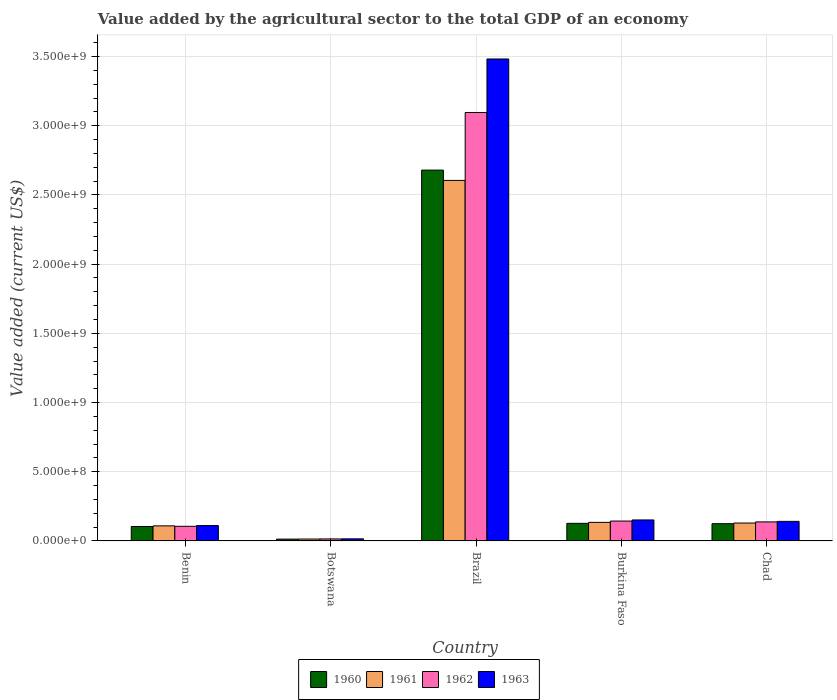How many different coloured bars are there?
Keep it short and to the point. 4. Are the number of bars per tick equal to the number of legend labels?
Make the answer very short. Yes. Are the number of bars on each tick of the X-axis equal?
Provide a short and direct response. Yes. What is the label of the 4th group of bars from the left?
Make the answer very short. Burkina Faso. In how many cases, is the number of bars for a given country not equal to the number of legend labels?
Give a very brief answer. 0. What is the value added by the agricultural sector to the total GDP in 1960 in Brazil?
Provide a short and direct response. 2.68e+09. Across all countries, what is the maximum value added by the agricultural sector to the total GDP in 1960?
Ensure brevity in your answer.  2.68e+09. Across all countries, what is the minimum value added by the agricultural sector to the total GDP in 1963?
Offer a terse response. 1.51e+07. In which country was the value added by the agricultural sector to the total GDP in 1960 minimum?
Keep it short and to the point. Botswana. What is the total value added by the agricultural sector to the total GDP in 1961 in the graph?
Your answer should be compact. 2.99e+09. What is the difference between the value added by the agricultural sector to the total GDP in 1962 in Botswana and that in Chad?
Provide a short and direct response. -1.23e+08. What is the difference between the value added by the agricultural sector to the total GDP in 1963 in Chad and the value added by the agricultural sector to the total GDP in 1961 in Burkina Faso?
Offer a terse response. 7.20e+06. What is the average value added by the agricultural sector to the total GDP in 1963 per country?
Provide a succinct answer. 7.80e+08. What is the difference between the value added by the agricultural sector to the total GDP of/in 1962 and value added by the agricultural sector to the total GDP of/in 1961 in Benin?
Make the answer very short. -3.16e+06. What is the ratio of the value added by the agricultural sector to the total GDP in 1961 in Benin to that in Burkina Faso?
Offer a terse response. 0.81. Is the difference between the value added by the agricultural sector to the total GDP in 1962 in Botswana and Chad greater than the difference between the value added by the agricultural sector to the total GDP in 1961 in Botswana and Chad?
Offer a terse response. No. What is the difference between the highest and the second highest value added by the agricultural sector to the total GDP in 1960?
Your response must be concise. -2.55e+09. What is the difference between the highest and the lowest value added by the agricultural sector to the total GDP in 1960?
Provide a short and direct response. 2.67e+09. Is the sum of the value added by the agricultural sector to the total GDP in 1960 in Botswana and Burkina Faso greater than the maximum value added by the agricultural sector to the total GDP in 1961 across all countries?
Ensure brevity in your answer.  No. What does the 4th bar from the left in Benin represents?
Provide a short and direct response. 1963. Is it the case that in every country, the sum of the value added by the agricultural sector to the total GDP in 1963 and value added by the agricultural sector to the total GDP in 1960 is greater than the value added by the agricultural sector to the total GDP in 1962?
Keep it short and to the point. Yes. How many bars are there?
Offer a terse response. 20. How many countries are there in the graph?
Provide a short and direct response. 5. What is the difference between two consecutive major ticks on the Y-axis?
Offer a terse response. 5.00e+08. Are the values on the major ticks of Y-axis written in scientific E-notation?
Your answer should be compact. Yes. Does the graph contain grids?
Your answer should be very brief. Yes. Where does the legend appear in the graph?
Provide a succinct answer. Bottom center. What is the title of the graph?
Keep it short and to the point. Value added by the agricultural sector to the total GDP of an economy. What is the label or title of the Y-axis?
Your answer should be compact. Value added (current US$). What is the Value added (current US$) of 1960 in Benin?
Your response must be concise. 1.04e+08. What is the Value added (current US$) in 1961 in Benin?
Keep it short and to the point. 1.09e+08. What is the Value added (current US$) in 1962 in Benin?
Make the answer very short. 1.06e+08. What is the Value added (current US$) of 1963 in Benin?
Give a very brief answer. 1.11e+08. What is the Value added (current US$) in 1960 in Botswana?
Provide a succinct answer. 1.31e+07. What is the Value added (current US$) in 1961 in Botswana?
Your response must be concise. 1.38e+07. What is the Value added (current US$) in 1962 in Botswana?
Provide a succinct answer. 1.45e+07. What is the Value added (current US$) of 1963 in Botswana?
Make the answer very short. 1.51e+07. What is the Value added (current US$) of 1960 in Brazil?
Make the answer very short. 2.68e+09. What is the Value added (current US$) in 1961 in Brazil?
Keep it short and to the point. 2.60e+09. What is the Value added (current US$) in 1962 in Brazil?
Provide a short and direct response. 3.10e+09. What is the Value added (current US$) in 1963 in Brazil?
Your answer should be compact. 3.48e+09. What is the Value added (current US$) in 1960 in Burkina Faso?
Make the answer very short. 1.27e+08. What is the Value added (current US$) of 1961 in Burkina Faso?
Ensure brevity in your answer.  1.34e+08. What is the Value added (current US$) in 1962 in Burkina Faso?
Provide a short and direct response. 1.44e+08. What is the Value added (current US$) in 1963 in Burkina Faso?
Your answer should be very brief. 1.52e+08. What is the Value added (current US$) of 1960 in Chad?
Offer a very short reply. 1.25e+08. What is the Value added (current US$) in 1961 in Chad?
Your answer should be compact. 1.29e+08. What is the Value added (current US$) in 1962 in Chad?
Ensure brevity in your answer.  1.38e+08. What is the Value added (current US$) in 1963 in Chad?
Offer a terse response. 1.41e+08. Across all countries, what is the maximum Value added (current US$) in 1960?
Your answer should be very brief. 2.68e+09. Across all countries, what is the maximum Value added (current US$) in 1961?
Keep it short and to the point. 2.60e+09. Across all countries, what is the maximum Value added (current US$) in 1962?
Provide a short and direct response. 3.10e+09. Across all countries, what is the maximum Value added (current US$) of 1963?
Provide a short and direct response. 3.48e+09. Across all countries, what is the minimum Value added (current US$) in 1960?
Offer a terse response. 1.31e+07. Across all countries, what is the minimum Value added (current US$) of 1961?
Offer a terse response. 1.38e+07. Across all countries, what is the minimum Value added (current US$) of 1962?
Ensure brevity in your answer.  1.45e+07. Across all countries, what is the minimum Value added (current US$) of 1963?
Keep it short and to the point. 1.51e+07. What is the total Value added (current US$) of 1960 in the graph?
Make the answer very short. 3.05e+09. What is the total Value added (current US$) in 1961 in the graph?
Provide a succinct answer. 2.99e+09. What is the total Value added (current US$) in 1962 in the graph?
Give a very brief answer. 3.50e+09. What is the total Value added (current US$) of 1963 in the graph?
Your answer should be very brief. 3.90e+09. What is the difference between the Value added (current US$) of 1960 in Benin and that in Botswana?
Ensure brevity in your answer.  9.13e+07. What is the difference between the Value added (current US$) in 1961 in Benin and that in Botswana?
Your answer should be very brief. 9.51e+07. What is the difference between the Value added (current US$) in 1962 in Benin and that in Botswana?
Provide a short and direct response. 9.12e+07. What is the difference between the Value added (current US$) of 1963 in Benin and that in Botswana?
Give a very brief answer. 9.59e+07. What is the difference between the Value added (current US$) in 1960 in Benin and that in Brazil?
Give a very brief answer. -2.57e+09. What is the difference between the Value added (current US$) in 1961 in Benin and that in Brazil?
Provide a succinct answer. -2.50e+09. What is the difference between the Value added (current US$) of 1962 in Benin and that in Brazil?
Provide a succinct answer. -2.99e+09. What is the difference between the Value added (current US$) of 1963 in Benin and that in Brazil?
Keep it short and to the point. -3.37e+09. What is the difference between the Value added (current US$) of 1960 in Benin and that in Burkina Faso?
Ensure brevity in your answer.  -2.28e+07. What is the difference between the Value added (current US$) of 1961 in Benin and that in Burkina Faso?
Give a very brief answer. -2.53e+07. What is the difference between the Value added (current US$) of 1962 in Benin and that in Burkina Faso?
Your response must be concise. -3.80e+07. What is the difference between the Value added (current US$) in 1963 in Benin and that in Burkina Faso?
Offer a very short reply. -4.07e+07. What is the difference between the Value added (current US$) of 1960 in Benin and that in Chad?
Offer a terse response. -2.02e+07. What is the difference between the Value added (current US$) of 1961 in Benin and that in Chad?
Give a very brief answer. -2.05e+07. What is the difference between the Value added (current US$) of 1962 in Benin and that in Chad?
Provide a short and direct response. -3.19e+07. What is the difference between the Value added (current US$) in 1963 in Benin and that in Chad?
Offer a terse response. -3.04e+07. What is the difference between the Value added (current US$) of 1960 in Botswana and that in Brazil?
Provide a short and direct response. -2.67e+09. What is the difference between the Value added (current US$) in 1961 in Botswana and that in Brazil?
Your response must be concise. -2.59e+09. What is the difference between the Value added (current US$) of 1962 in Botswana and that in Brazil?
Give a very brief answer. -3.08e+09. What is the difference between the Value added (current US$) in 1963 in Botswana and that in Brazil?
Your response must be concise. -3.47e+09. What is the difference between the Value added (current US$) of 1960 in Botswana and that in Burkina Faso?
Give a very brief answer. -1.14e+08. What is the difference between the Value added (current US$) in 1961 in Botswana and that in Burkina Faso?
Make the answer very short. -1.20e+08. What is the difference between the Value added (current US$) in 1962 in Botswana and that in Burkina Faso?
Your answer should be very brief. -1.29e+08. What is the difference between the Value added (current US$) of 1963 in Botswana and that in Burkina Faso?
Your answer should be very brief. -1.37e+08. What is the difference between the Value added (current US$) in 1960 in Botswana and that in Chad?
Your answer should be very brief. -1.11e+08. What is the difference between the Value added (current US$) of 1961 in Botswana and that in Chad?
Provide a succinct answer. -1.16e+08. What is the difference between the Value added (current US$) in 1962 in Botswana and that in Chad?
Your answer should be very brief. -1.23e+08. What is the difference between the Value added (current US$) in 1963 in Botswana and that in Chad?
Your answer should be very brief. -1.26e+08. What is the difference between the Value added (current US$) of 1960 in Brazil and that in Burkina Faso?
Offer a terse response. 2.55e+09. What is the difference between the Value added (current US$) in 1961 in Brazil and that in Burkina Faso?
Ensure brevity in your answer.  2.47e+09. What is the difference between the Value added (current US$) in 1962 in Brazil and that in Burkina Faso?
Your answer should be very brief. 2.95e+09. What is the difference between the Value added (current US$) in 1963 in Brazil and that in Burkina Faso?
Keep it short and to the point. 3.33e+09. What is the difference between the Value added (current US$) in 1960 in Brazil and that in Chad?
Keep it short and to the point. 2.55e+09. What is the difference between the Value added (current US$) of 1961 in Brazil and that in Chad?
Make the answer very short. 2.48e+09. What is the difference between the Value added (current US$) of 1962 in Brazil and that in Chad?
Offer a very short reply. 2.96e+09. What is the difference between the Value added (current US$) in 1963 in Brazil and that in Chad?
Your answer should be very brief. 3.34e+09. What is the difference between the Value added (current US$) of 1960 in Burkina Faso and that in Chad?
Give a very brief answer. 2.61e+06. What is the difference between the Value added (current US$) of 1961 in Burkina Faso and that in Chad?
Make the answer very short. 4.79e+06. What is the difference between the Value added (current US$) of 1962 in Burkina Faso and that in Chad?
Offer a very short reply. 6.10e+06. What is the difference between the Value added (current US$) of 1963 in Burkina Faso and that in Chad?
Offer a terse response. 1.03e+07. What is the difference between the Value added (current US$) of 1960 in Benin and the Value added (current US$) of 1961 in Botswana?
Make the answer very short. 9.06e+07. What is the difference between the Value added (current US$) in 1960 in Benin and the Value added (current US$) in 1962 in Botswana?
Make the answer very short. 8.99e+07. What is the difference between the Value added (current US$) of 1960 in Benin and the Value added (current US$) of 1963 in Botswana?
Provide a short and direct response. 8.93e+07. What is the difference between the Value added (current US$) in 1961 in Benin and the Value added (current US$) in 1962 in Botswana?
Make the answer very short. 9.44e+07. What is the difference between the Value added (current US$) of 1961 in Benin and the Value added (current US$) of 1963 in Botswana?
Offer a terse response. 9.37e+07. What is the difference between the Value added (current US$) of 1962 in Benin and the Value added (current US$) of 1963 in Botswana?
Make the answer very short. 9.06e+07. What is the difference between the Value added (current US$) of 1960 in Benin and the Value added (current US$) of 1961 in Brazil?
Your response must be concise. -2.50e+09. What is the difference between the Value added (current US$) of 1960 in Benin and the Value added (current US$) of 1962 in Brazil?
Your response must be concise. -2.99e+09. What is the difference between the Value added (current US$) of 1960 in Benin and the Value added (current US$) of 1963 in Brazil?
Provide a succinct answer. -3.38e+09. What is the difference between the Value added (current US$) of 1961 in Benin and the Value added (current US$) of 1962 in Brazil?
Provide a short and direct response. -2.99e+09. What is the difference between the Value added (current US$) of 1961 in Benin and the Value added (current US$) of 1963 in Brazil?
Offer a terse response. -3.37e+09. What is the difference between the Value added (current US$) of 1962 in Benin and the Value added (current US$) of 1963 in Brazil?
Keep it short and to the point. -3.38e+09. What is the difference between the Value added (current US$) of 1960 in Benin and the Value added (current US$) of 1961 in Burkina Faso?
Provide a succinct answer. -2.98e+07. What is the difference between the Value added (current US$) in 1960 in Benin and the Value added (current US$) in 1962 in Burkina Faso?
Your answer should be very brief. -3.93e+07. What is the difference between the Value added (current US$) in 1960 in Benin and the Value added (current US$) in 1963 in Burkina Faso?
Ensure brevity in your answer.  -4.73e+07. What is the difference between the Value added (current US$) of 1961 in Benin and the Value added (current US$) of 1962 in Burkina Faso?
Make the answer very short. -3.48e+07. What is the difference between the Value added (current US$) in 1961 in Benin and the Value added (current US$) in 1963 in Burkina Faso?
Your response must be concise. -4.28e+07. What is the difference between the Value added (current US$) of 1962 in Benin and the Value added (current US$) of 1963 in Burkina Faso?
Your answer should be compact. -4.60e+07. What is the difference between the Value added (current US$) in 1960 in Benin and the Value added (current US$) in 1961 in Chad?
Your answer should be compact. -2.50e+07. What is the difference between the Value added (current US$) in 1960 in Benin and the Value added (current US$) in 1962 in Chad?
Offer a terse response. -3.32e+07. What is the difference between the Value added (current US$) in 1960 in Benin and the Value added (current US$) in 1963 in Chad?
Ensure brevity in your answer.  -3.70e+07. What is the difference between the Value added (current US$) in 1961 in Benin and the Value added (current US$) in 1962 in Chad?
Your answer should be compact. -2.87e+07. What is the difference between the Value added (current US$) of 1961 in Benin and the Value added (current US$) of 1963 in Chad?
Give a very brief answer. -3.25e+07. What is the difference between the Value added (current US$) of 1962 in Benin and the Value added (current US$) of 1963 in Chad?
Offer a very short reply. -3.57e+07. What is the difference between the Value added (current US$) in 1960 in Botswana and the Value added (current US$) in 1961 in Brazil?
Your answer should be very brief. -2.59e+09. What is the difference between the Value added (current US$) of 1960 in Botswana and the Value added (current US$) of 1962 in Brazil?
Ensure brevity in your answer.  -3.08e+09. What is the difference between the Value added (current US$) of 1960 in Botswana and the Value added (current US$) of 1963 in Brazil?
Provide a succinct answer. -3.47e+09. What is the difference between the Value added (current US$) in 1961 in Botswana and the Value added (current US$) in 1962 in Brazil?
Provide a succinct answer. -3.08e+09. What is the difference between the Value added (current US$) of 1961 in Botswana and the Value added (current US$) of 1963 in Brazil?
Ensure brevity in your answer.  -3.47e+09. What is the difference between the Value added (current US$) of 1962 in Botswana and the Value added (current US$) of 1963 in Brazil?
Your answer should be very brief. -3.47e+09. What is the difference between the Value added (current US$) of 1960 in Botswana and the Value added (current US$) of 1961 in Burkina Faso?
Make the answer very short. -1.21e+08. What is the difference between the Value added (current US$) in 1960 in Botswana and the Value added (current US$) in 1962 in Burkina Faso?
Ensure brevity in your answer.  -1.31e+08. What is the difference between the Value added (current US$) in 1960 in Botswana and the Value added (current US$) in 1963 in Burkina Faso?
Ensure brevity in your answer.  -1.39e+08. What is the difference between the Value added (current US$) of 1961 in Botswana and the Value added (current US$) of 1962 in Burkina Faso?
Make the answer very short. -1.30e+08. What is the difference between the Value added (current US$) of 1961 in Botswana and the Value added (current US$) of 1963 in Burkina Faso?
Provide a short and direct response. -1.38e+08. What is the difference between the Value added (current US$) in 1962 in Botswana and the Value added (current US$) in 1963 in Burkina Faso?
Provide a succinct answer. -1.37e+08. What is the difference between the Value added (current US$) of 1960 in Botswana and the Value added (current US$) of 1961 in Chad?
Make the answer very short. -1.16e+08. What is the difference between the Value added (current US$) of 1960 in Botswana and the Value added (current US$) of 1962 in Chad?
Your answer should be very brief. -1.24e+08. What is the difference between the Value added (current US$) in 1960 in Botswana and the Value added (current US$) in 1963 in Chad?
Make the answer very short. -1.28e+08. What is the difference between the Value added (current US$) of 1961 in Botswana and the Value added (current US$) of 1962 in Chad?
Your answer should be very brief. -1.24e+08. What is the difference between the Value added (current US$) in 1961 in Botswana and the Value added (current US$) in 1963 in Chad?
Your answer should be compact. -1.28e+08. What is the difference between the Value added (current US$) in 1962 in Botswana and the Value added (current US$) in 1963 in Chad?
Provide a succinct answer. -1.27e+08. What is the difference between the Value added (current US$) in 1960 in Brazil and the Value added (current US$) in 1961 in Burkina Faso?
Provide a short and direct response. 2.55e+09. What is the difference between the Value added (current US$) in 1960 in Brazil and the Value added (current US$) in 1962 in Burkina Faso?
Ensure brevity in your answer.  2.54e+09. What is the difference between the Value added (current US$) of 1960 in Brazil and the Value added (current US$) of 1963 in Burkina Faso?
Your response must be concise. 2.53e+09. What is the difference between the Value added (current US$) in 1961 in Brazil and the Value added (current US$) in 1962 in Burkina Faso?
Your answer should be very brief. 2.46e+09. What is the difference between the Value added (current US$) in 1961 in Brazil and the Value added (current US$) in 1963 in Burkina Faso?
Give a very brief answer. 2.45e+09. What is the difference between the Value added (current US$) of 1962 in Brazil and the Value added (current US$) of 1963 in Burkina Faso?
Provide a succinct answer. 2.94e+09. What is the difference between the Value added (current US$) in 1960 in Brazil and the Value added (current US$) in 1961 in Chad?
Ensure brevity in your answer.  2.55e+09. What is the difference between the Value added (current US$) in 1960 in Brazil and the Value added (current US$) in 1962 in Chad?
Provide a short and direct response. 2.54e+09. What is the difference between the Value added (current US$) of 1960 in Brazil and the Value added (current US$) of 1963 in Chad?
Offer a terse response. 2.54e+09. What is the difference between the Value added (current US$) in 1961 in Brazil and the Value added (current US$) in 1962 in Chad?
Provide a succinct answer. 2.47e+09. What is the difference between the Value added (current US$) of 1961 in Brazil and the Value added (current US$) of 1963 in Chad?
Your answer should be compact. 2.46e+09. What is the difference between the Value added (current US$) in 1962 in Brazil and the Value added (current US$) in 1963 in Chad?
Ensure brevity in your answer.  2.95e+09. What is the difference between the Value added (current US$) in 1960 in Burkina Faso and the Value added (current US$) in 1961 in Chad?
Offer a very short reply. -2.21e+06. What is the difference between the Value added (current US$) in 1960 in Burkina Faso and the Value added (current US$) in 1962 in Chad?
Make the answer very short. -1.04e+07. What is the difference between the Value added (current US$) of 1960 in Burkina Faso and the Value added (current US$) of 1963 in Chad?
Ensure brevity in your answer.  -1.42e+07. What is the difference between the Value added (current US$) in 1961 in Burkina Faso and the Value added (current US$) in 1962 in Chad?
Keep it short and to the point. -3.43e+06. What is the difference between the Value added (current US$) of 1961 in Burkina Faso and the Value added (current US$) of 1963 in Chad?
Offer a terse response. -7.20e+06. What is the difference between the Value added (current US$) of 1962 in Burkina Faso and the Value added (current US$) of 1963 in Chad?
Provide a succinct answer. 2.33e+06. What is the average Value added (current US$) of 1960 per country?
Offer a very short reply. 6.10e+08. What is the average Value added (current US$) in 1961 per country?
Offer a terse response. 5.98e+08. What is the average Value added (current US$) in 1962 per country?
Your response must be concise. 6.99e+08. What is the average Value added (current US$) in 1963 per country?
Your answer should be very brief. 7.80e+08. What is the difference between the Value added (current US$) of 1960 and Value added (current US$) of 1961 in Benin?
Your answer should be compact. -4.46e+06. What is the difference between the Value added (current US$) of 1960 and Value added (current US$) of 1962 in Benin?
Keep it short and to the point. -1.30e+06. What is the difference between the Value added (current US$) of 1960 and Value added (current US$) of 1963 in Benin?
Offer a very short reply. -6.61e+06. What is the difference between the Value added (current US$) in 1961 and Value added (current US$) in 1962 in Benin?
Your answer should be very brief. 3.16e+06. What is the difference between the Value added (current US$) of 1961 and Value added (current US$) of 1963 in Benin?
Offer a terse response. -2.15e+06. What is the difference between the Value added (current US$) of 1962 and Value added (current US$) of 1963 in Benin?
Make the answer very short. -5.30e+06. What is the difference between the Value added (current US$) of 1960 and Value added (current US$) of 1961 in Botswana?
Keep it short and to the point. -6.50e+05. What is the difference between the Value added (current US$) in 1960 and Value added (current US$) in 1962 in Botswana?
Offer a terse response. -1.35e+06. What is the difference between the Value added (current US$) of 1960 and Value added (current US$) of 1963 in Botswana?
Your answer should be compact. -1.99e+06. What is the difference between the Value added (current US$) in 1961 and Value added (current US$) in 1962 in Botswana?
Offer a terse response. -7.04e+05. What is the difference between the Value added (current US$) of 1961 and Value added (current US$) of 1963 in Botswana?
Your answer should be compact. -1.34e+06. What is the difference between the Value added (current US$) in 1962 and Value added (current US$) in 1963 in Botswana?
Keep it short and to the point. -6.34e+05. What is the difference between the Value added (current US$) of 1960 and Value added (current US$) of 1961 in Brazil?
Your response must be concise. 7.45e+07. What is the difference between the Value added (current US$) of 1960 and Value added (current US$) of 1962 in Brazil?
Offer a very short reply. -4.16e+08. What is the difference between the Value added (current US$) of 1960 and Value added (current US$) of 1963 in Brazil?
Provide a short and direct response. -8.03e+08. What is the difference between the Value added (current US$) of 1961 and Value added (current US$) of 1962 in Brazil?
Your answer should be very brief. -4.91e+08. What is the difference between the Value added (current US$) of 1961 and Value added (current US$) of 1963 in Brazil?
Offer a terse response. -8.77e+08. What is the difference between the Value added (current US$) in 1962 and Value added (current US$) in 1963 in Brazil?
Your answer should be very brief. -3.87e+08. What is the difference between the Value added (current US$) in 1960 and Value added (current US$) in 1961 in Burkina Faso?
Offer a terse response. -7.00e+06. What is the difference between the Value added (current US$) in 1960 and Value added (current US$) in 1962 in Burkina Faso?
Your response must be concise. -1.65e+07. What is the difference between the Value added (current US$) in 1960 and Value added (current US$) in 1963 in Burkina Faso?
Provide a succinct answer. -2.45e+07. What is the difference between the Value added (current US$) of 1961 and Value added (current US$) of 1962 in Burkina Faso?
Provide a short and direct response. -9.53e+06. What is the difference between the Value added (current US$) in 1961 and Value added (current US$) in 1963 in Burkina Faso?
Give a very brief answer. -1.75e+07. What is the difference between the Value added (current US$) of 1962 and Value added (current US$) of 1963 in Burkina Faso?
Provide a short and direct response. -7.98e+06. What is the difference between the Value added (current US$) in 1960 and Value added (current US$) in 1961 in Chad?
Provide a short and direct response. -4.82e+06. What is the difference between the Value added (current US$) in 1960 and Value added (current US$) in 1962 in Chad?
Make the answer very short. -1.30e+07. What is the difference between the Value added (current US$) of 1960 and Value added (current US$) of 1963 in Chad?
Give a very brief answer. -1.68e+07. What is the difference between the Value added (current US$) in 1961 and Value added (current US$) in 1962 in Chad?
Your answer should be very brief. -8.22e+06. What is the difference between the Value added (current US$) of 1961 and Value added (current US$) of 1963 in Chad?
Your response must be concise. -1.20e+07. What is the difference between the Value added (current US$) in 1962 and Value added (current US$) in 1963 in Chad?
Provide a succinct answer. -3.78e+06. What is the ratio of the Value added (current US$) in 1960 in Benin to that in Botswana?
Offer a very short reply. 7.94. What is the ratio of the Value added (current US$) in 1961 in Benin to that in Botswana?
Provide a succinct answer. 7.89. What is the ratio of the Value added (current US$) of 1962 in Benin to that in Botswana?
Provide a succinct answer. 7.29. What is the ratio of the Value added (current US$) in 1963 in Benin to that in Botswana?
Make the answer very short. 7.34. What is the ratio of the Value added (current US$) in 1960 in Benin to that in Brazil?
Provide a succinct answer. 0.04. What is the ratio of the Value added (current US$) of 1961 in Benin to that in Brazil?
Provide a succinct answer. 0.04. What is the ratio of the Value added (current US$) of 1962 in Benin to that in Brazil?
Offer a very short reply. 0.03. What is the ratio of the Value added (current US$) in 1963 in Benin to that in Brazil?
Offer a very short reply. 0.03. What is the ratio of the Value added (current US$) of 1960 in Benin to that in Burkina Faso?
Your answer should be very brief. 0.82. What is the ratio of the Value added (current US$) of 1961 in Benin to that in Burkina Faso?
Offer a terse response. 0.81. What is the ratio of the Value added (current US$) of 1962 in Benin to that in Burkina Faso?
Your answer should be compact. 0.74. What is the ratio of the Value added (current US$) of 1963 in Benin to that in Burkina Faso?
Offer a very short reply. 0.73. What is the ratio of the Value added (current US$) of 1960 in Benin to that in Chad?
Ensure brevity in your answer.  0.84. What is the ratio of the Value added (current US$) in 1961 in Benin to that in Chad?
Keep it short and to the point. 0.84. What is the ratio of the Value added (current US$) in 1962 in Benin to that in Chad?
Offer a very short reply. 0.77. What is the ratio of the Value added (current US$) in 1963 in Benin to that in Chad?
Provide a short and direct response. 0.79. What is the ratio of the Value added (current US$) in 1960 in Botswana to that in Brazil?
Your answer should be compact. 0. What is the ratio of the Value added (current US$) of 1961 in Botswana to that in Brazil?
Give a very brief answer. 0.01. What is the ratio of the Value added (current US$) of 1962 in Botswana to that in Brazil?
Provide a short and direct response. 0. What is the ratio of the Value added (current US$) in 1963 in Botswana to that in Brazil?
Give a very brief answer. 0. What is the ratio of the Value added (current US$) in 1960 in Botswana to that in Burkina Faso?
Keep it short and to the point. 0.1. What is the ratio of the Value added (current US$) in 1961 in Botswana to that in Burkina Faso?
Ensure brevity in your answer.  0.1. What is the ratio of the Value added (current US$) in 1962 in Botswana to that in Burkina Faso?
Your answer should be compact. 0.1. What is the ratio of the Value added (current US$) of 1963 in Botswana to that in Burkina Faso?
Ensure brevity in your answer.  0.1. What is the ratio of the Value added (current US$) in 1960 in Botswana to that in Chad?
Your response must be concise. 0.11. What is the ratio of the Value added (current US$) of 1961 in Botswana to that in Chad?
Offer a terse response. 0.11. What is the ratio of the Value added (current US$) of 1962 in Botswana to that in Chad?
Your answer should be compact. 0.11. What is the ratio of the Value added (current US$) of 1963 in Botswana to that in Chad?
Make the answer very short. 0.11. What is the ratio of the Value added (current US$) of 1960 in Brazil to that in Burkina Faso?
Your answer should be compact. 21.07. What is the ratio of the Value added (current US$) of 1961 in Brazil to that in Burkina Faso?
Keep it short and to the point. 19.41. What is the ratio of the Value added (current US$) of 1962 in Brazil to that in Burkina Faso?
Ensure brevity in your answer.  21.54. What is the ratio of the Value added (current US$) of 1963 in Brazil to that in Burkina Faso?
Give a very brief answer. 22.96. What is the ratio of the Value added (current US$) of 1960 in Brazil to that in Chad?
Give a very brief answer. 21.51. What is the ratio of the Value added (current US$) of 1961 in Brazil to that in Chad?
Offer a terse response. 20.13. What is the ratio of the Value added (current US$) of 1962 in Brazil to that in Chad?
Provide a succinct answer. 22.5. What is the ratio of the Value added (current US$) of 1963 in Brazil to that in Chad?
Offer a terse response. 24.63. What is the ratio of the Value added (current US$) in 1961 in Burkina Faso to that in Chad?
Offer a very short reply. 1.04. What is the ratio of the Value added (current US$) of 1962 in Burkina Faso to that in Chad?
Your response must be concise. 1.04. What is the ratio of the Value added (current US$) in 1963 in Burkina Faso to that in Chad?
Offer a terse response. 1.07. What is the difference between the highest and the second highest Value added (current US$) in 1960?
Your answer should be very brief. 2.55e+09. What is the difference between the highest and the second highest Value added (current US$) of 1961?
Your answer should be compact. 2.47e+09. What is the difference between the highest and the second highest Value added (current US$) of 1962?
Provide a short and direct response. 2.95e+09. What is the difference between the highest and the second highest Value added (current US$) of 1963?
Give a very brief answer. 3.33e+09. What is the difference between the highest and the lowest Value added (current US$) in 1960?
Provide a succinct answer. 2.67e+09. What is the difference between the highest and the lowest Value added (current US$) of 1961?
Make the answer very short. 2.59e+09. What is the difference between the highest and the lowest Value added (current US$) of 1962?
Provide a short and direct response. 3.08e+09. What is the difference between the highest and the lowest Value added (current US$) in 1963?
Provide a short and direct response. 3.47e+09. 